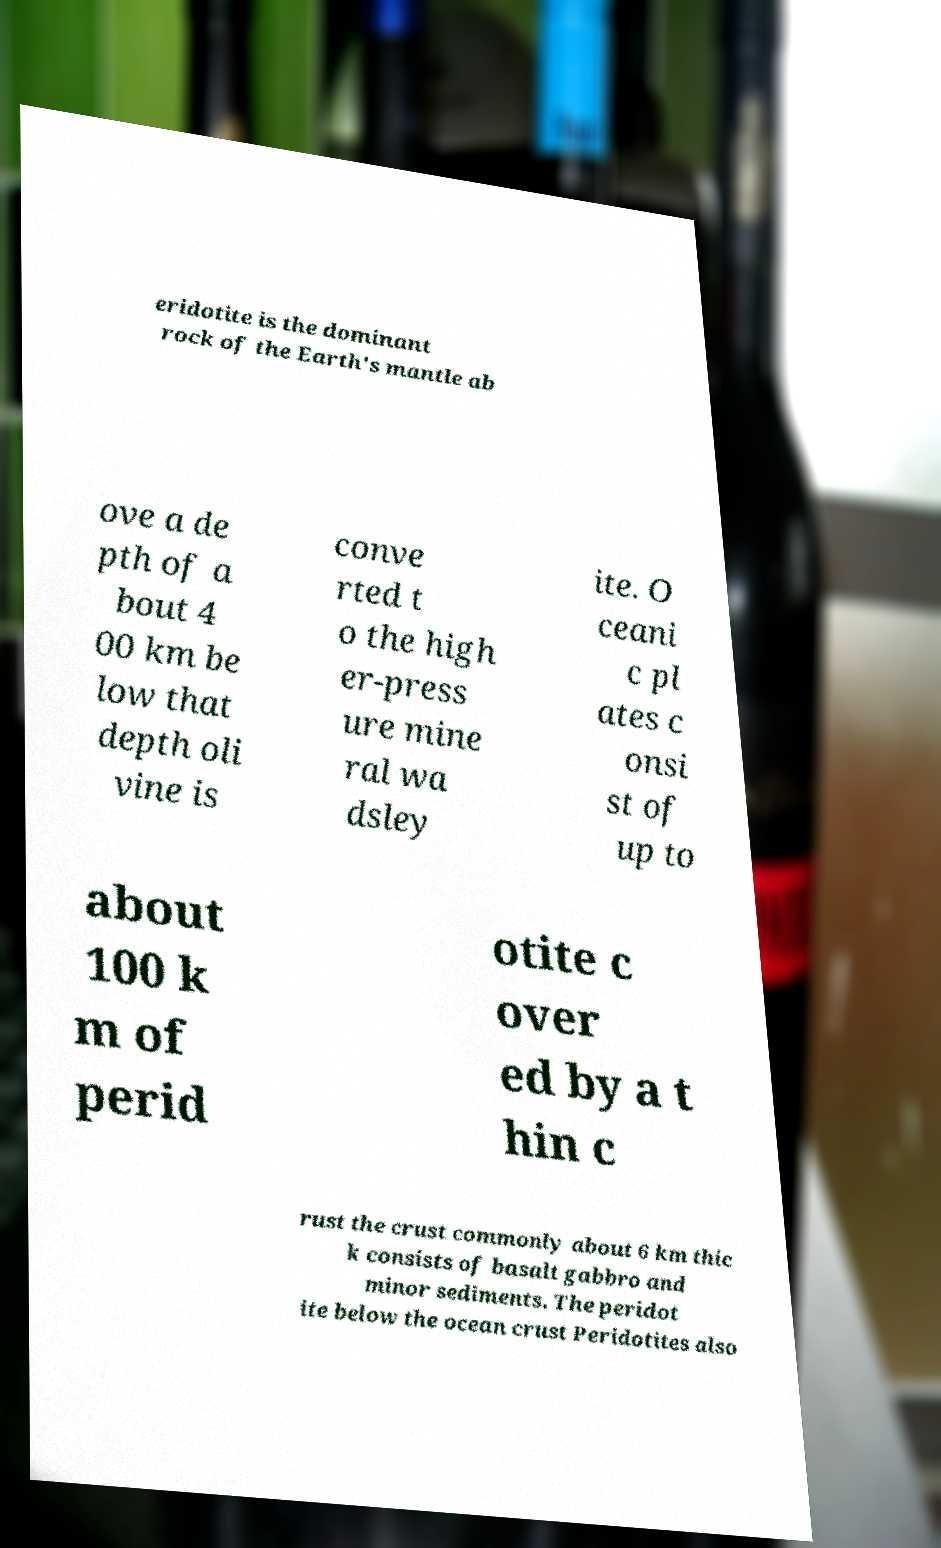Can you read and provide the text displayed in the image?This photo seems to have some interesting text. Can you extract and type it out for me? eridotite is the dominant rock of the Earth's mantle ab ove a de pth of a bout 4 00 km be low that depth oli vine is conve rted t o the high er-press ure mine ral wa dsley ite. O ceani c pl ates c onsi st of up to about 100 k m of perid otite c over ed by a t hin c rust the crust commonly about 6 km thic k consists of basalt gabbro and minor sediments. The peridot ite below the ocean crust Peridotites also 